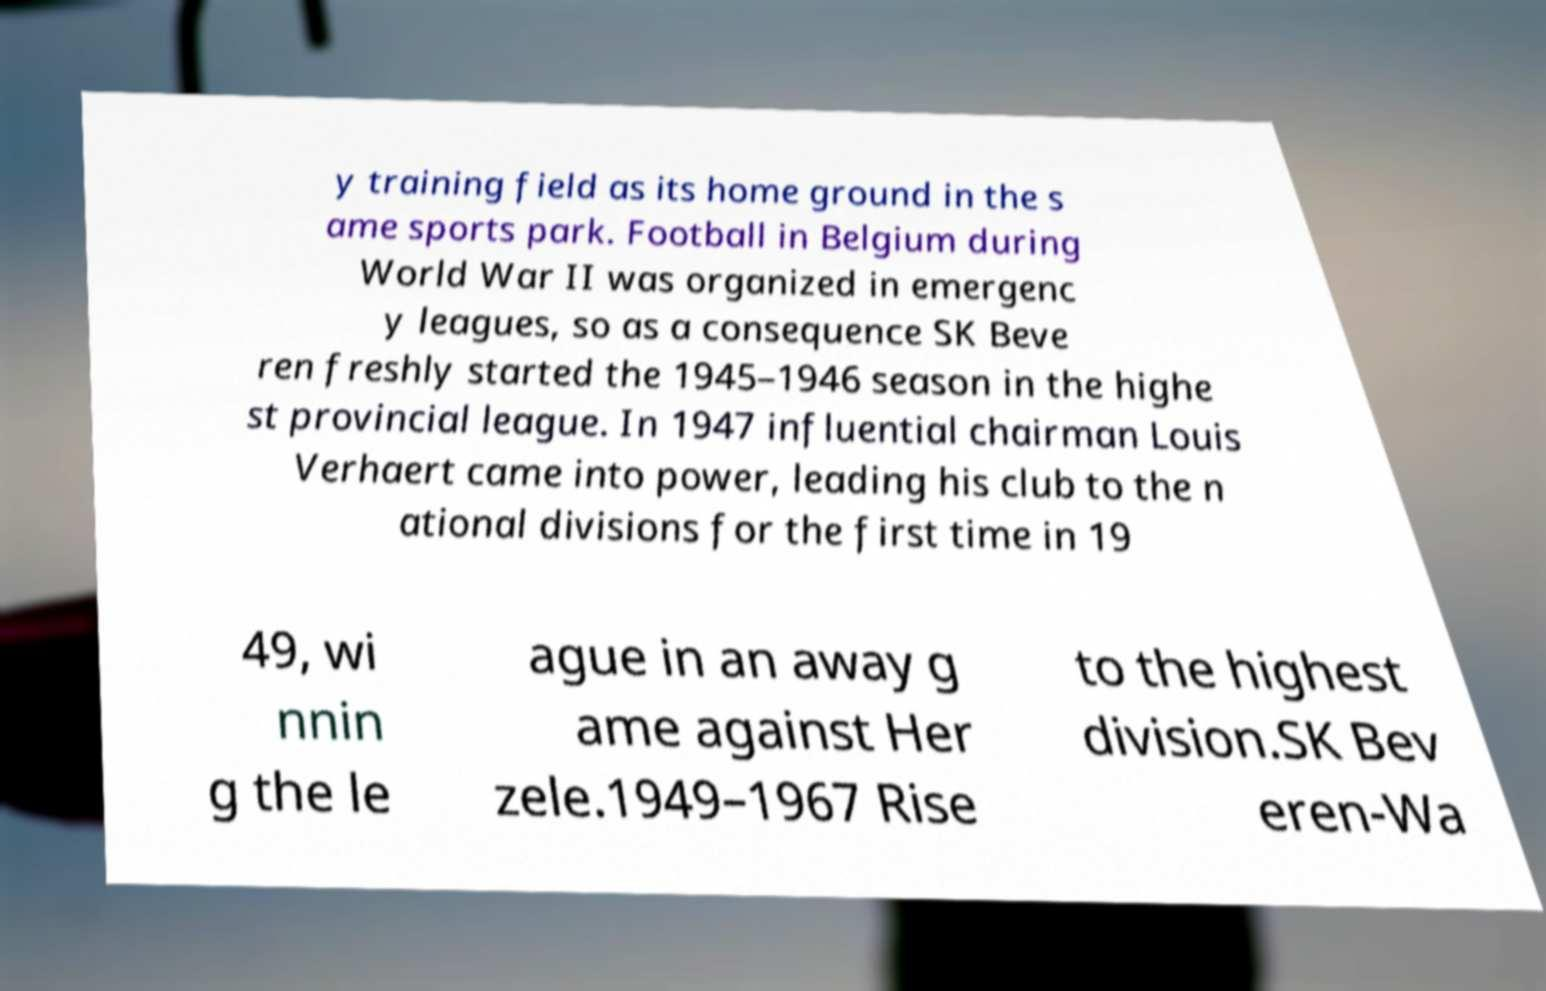I need the written content from this picture converted into text. Can you do that? y training field as its home ground in the s ame sports park. Football in Belgium during World War II was organized in emergenc y leagues, so as a consequence SK Beve ren freshly started the 1945–1946 season in the highe st provincial league. In 1947 influential chairman Louis Verhaert came into power, leading his club to the n ational divisions for the first time in 19 49, wi nnin g the le ague in an away g ame against Her zele.1949–1967 Rise to the highest division.SK Bev eren-Wa 